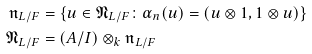<formula> <loc_0><loc_0><loc_500><loc_500>\mathfrak { n } _ { L / F } & = \{ u \in \mathfrak { N } _ { L / F } \colon \alpha _ { n } ( u ) = ( u \otimes 1 , 1 \otimes u ) \} \\ \mathfrak { N } _ { L / F } & = ( A / I ) \otimes _ { k } \mathfrak { n } _ { L / F }</formula> 